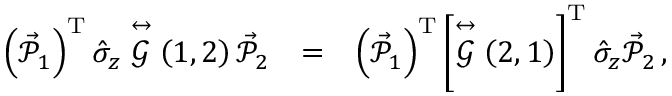Convert formula to latex. <formula><loc_0><loc_0><loc_500><loc_500>\begin{array} { r l r } { \left ( \vec { \mathcal { P } } _ { 1 } \right ) ^ { T } \hat { \sigma } _ { z } \stackrel { \leftrightarrow } { \mathcal { G } } \left ( 1 , 2 \right ) \vec { \mathcal { P } } _ { 2 } } & { = } & { \left ( \vec { \mathcal { P } } _ { 1 } \right ) ^ { T } \left [ \stackrel { \leftrightarrow } { \mathcal { G } } \left ( 2 , 1 \right ) \right ] ^ { T } \hat { \sigma } _ { z } \vec { \mathcal { P } } _ { 2 } \, , } \end{array}</formula> 